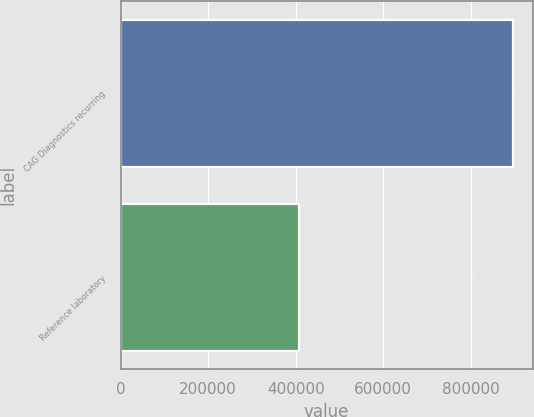<chart> <loc_0><loc_0><loc_500><loc_500><bar_chart><fcel>CAG Diagnostics recurring<fcel>Reference laboratory<nl><fcel>896449<fcel>407343<nl></chart> 